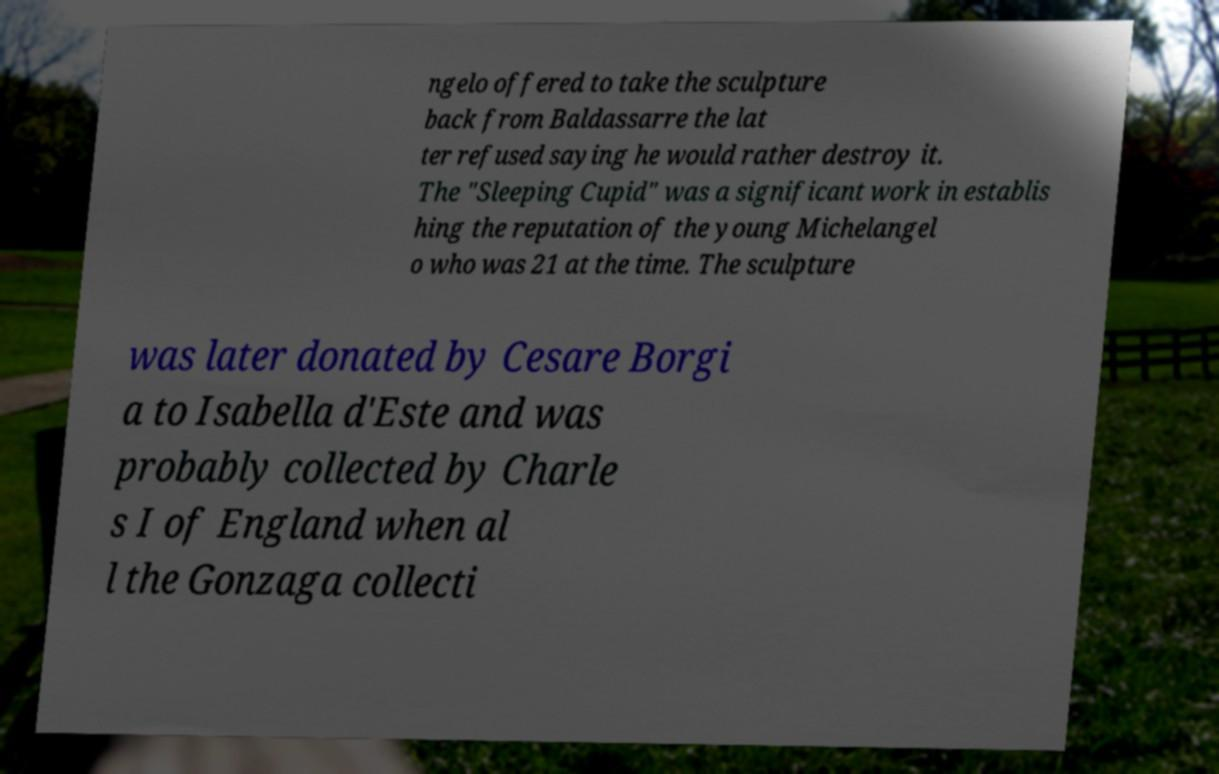There's text embedded in this image that I need extracted. Can you transcribe it verbatim? ngelo offered to take the sculpture back from Baldassarre the lat ter refused saying he would rather destroy it. The "Sleeping Cupid" was a significant work in establis hing the reputation of the young Michelangel o who was 21 at the time. The sculpture was later donated by Cesare Borgi a to Isabella d'Este and was probably collected by Charle s I of England when al l the Gonzaga collecti 